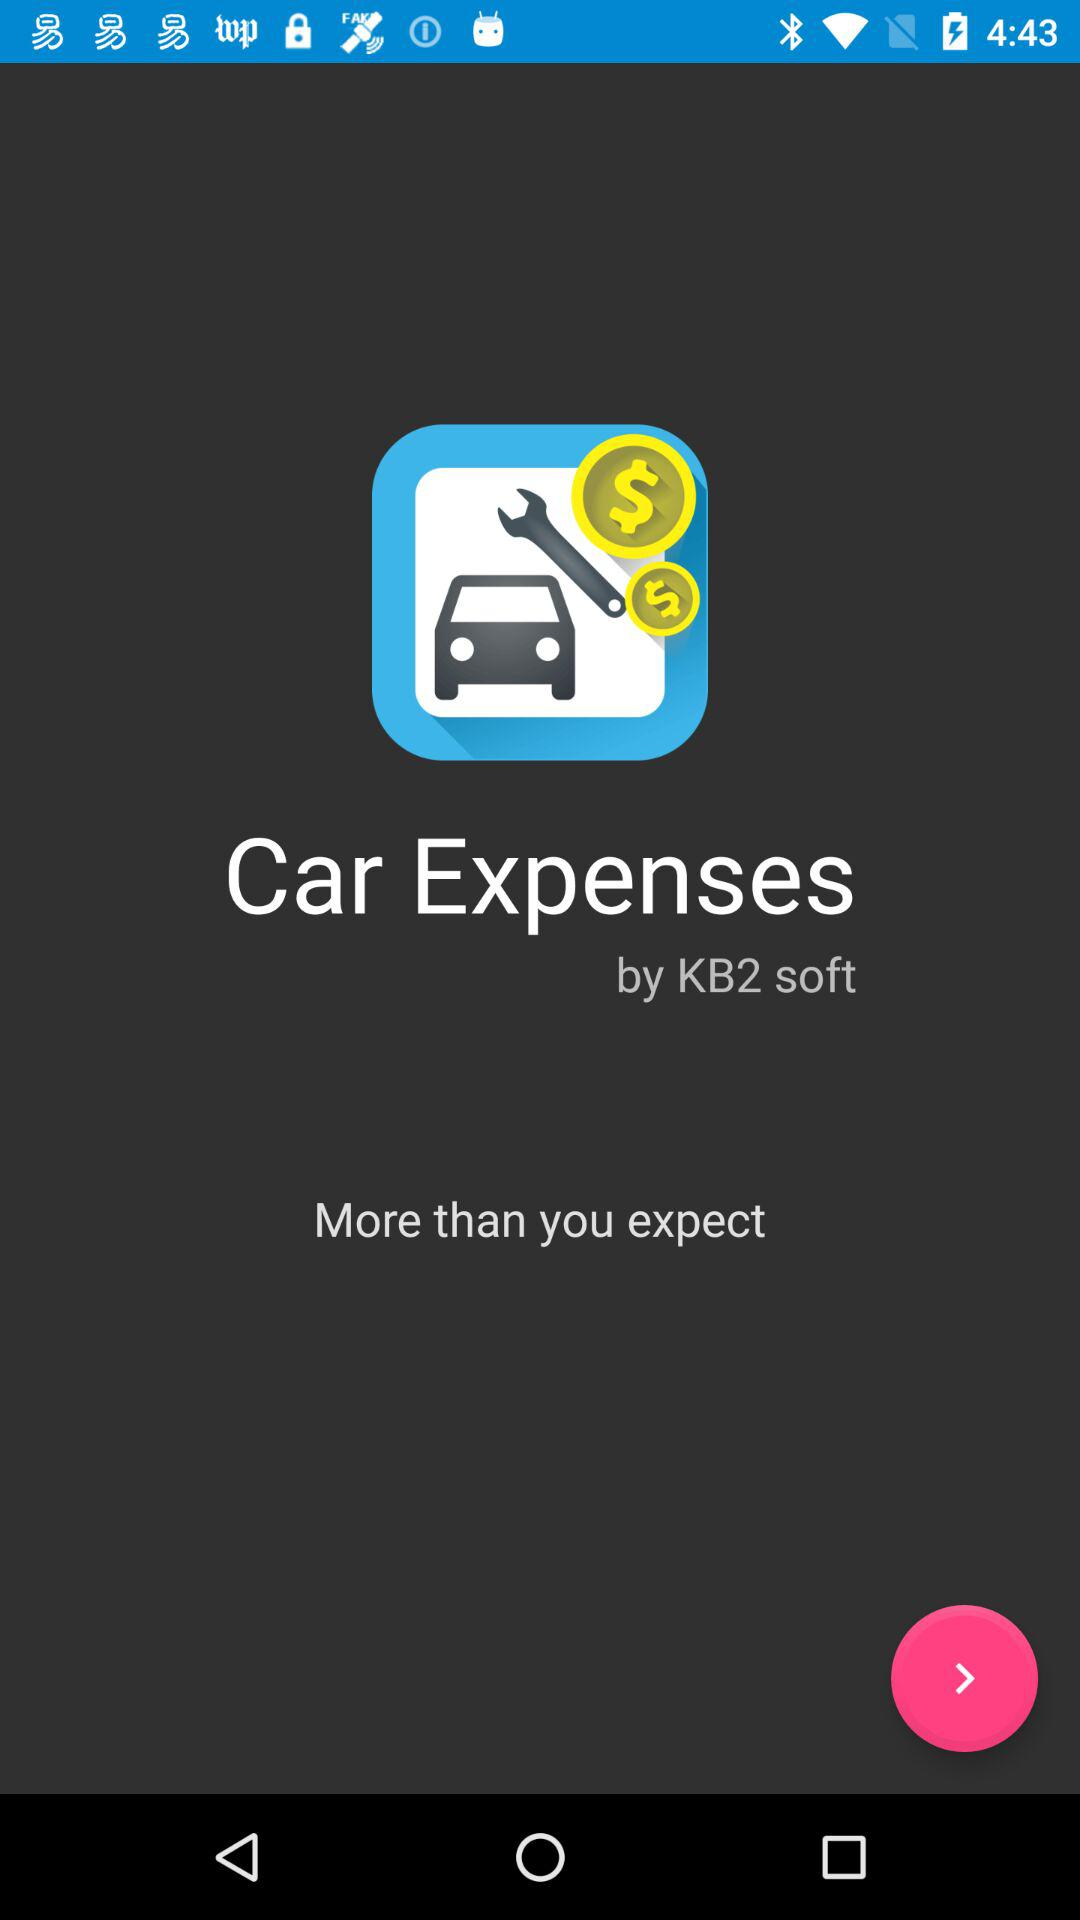What is the name of the application? The name of the application is "Car Expenses". 